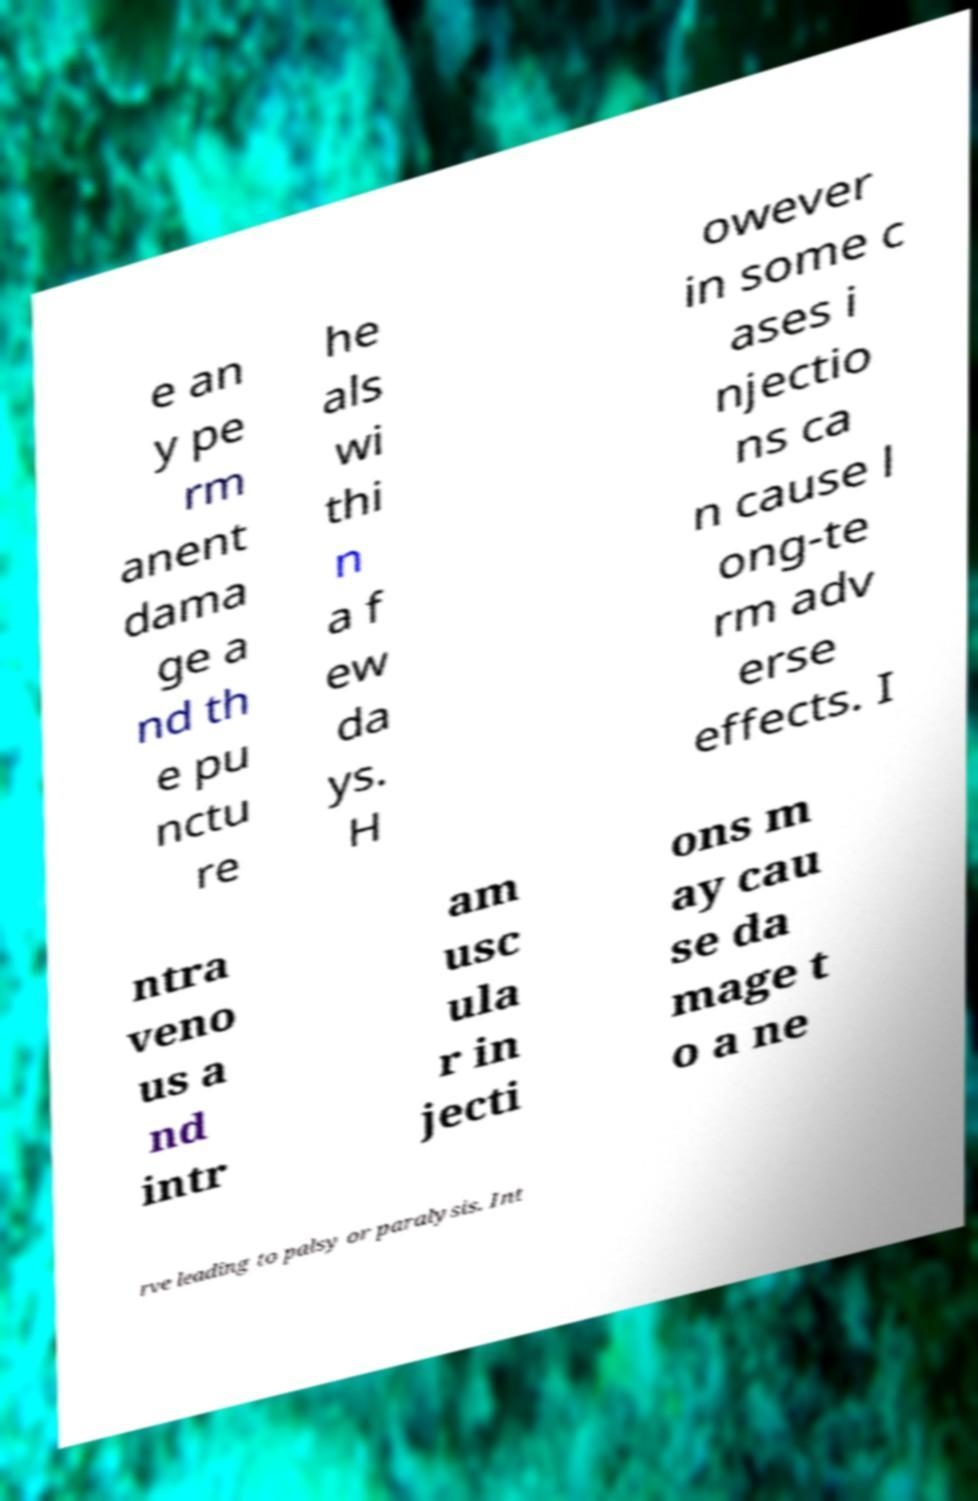Can you accurately transcribe the text from the provided image for me? e an y pe rm anent dama ge a nd th e pu nctu re he als wi thi n a f ew da ys. H owever in some c ases i njectio ns ca n cause l ong-te rm adv erse effects. I ntra veno us a nd intr am usc ula r in jecti ons m ay cau se da mage t o a ne rve leading to palsy or paralysis. Int 